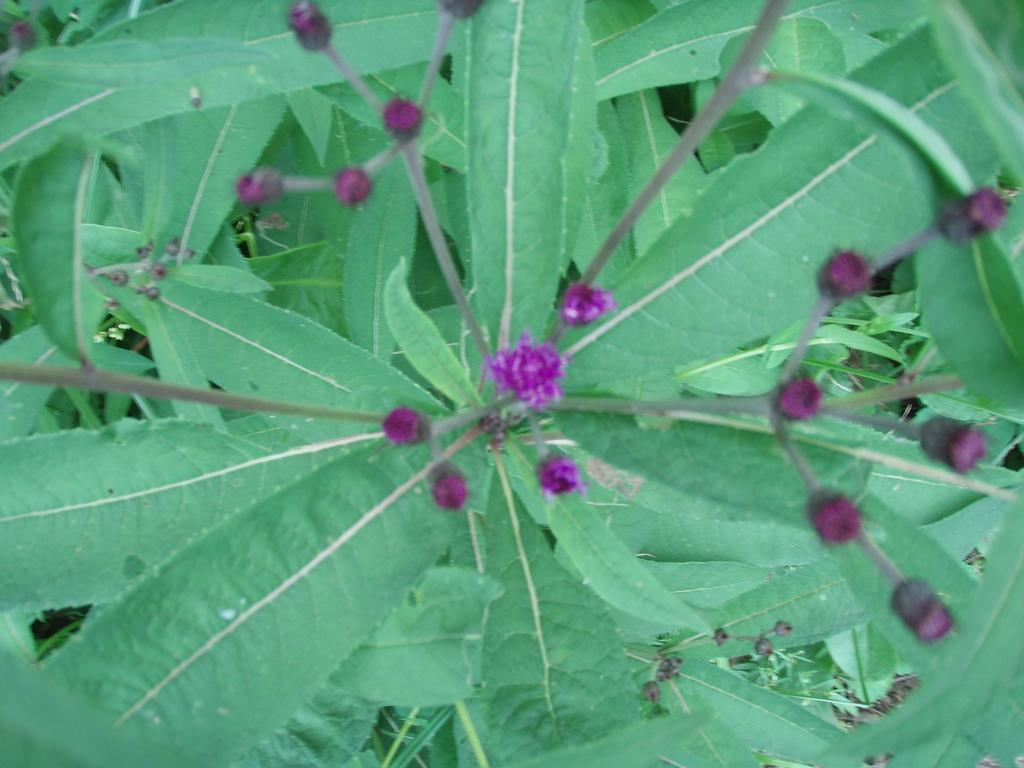What type of plant material can be seen in the image? There are leaves and buds in the image. Can you describe the stage of growth of the plant material? The presence of both leaves and buds suggests that the plant is in a stage of growth where it is producing both mature leaves and new growth. What type of horse can be seen in the image? There is no horse present in the image; it only contains leaves and buds. Can you tell me where the nearest store is in the image? There is no store present in the image; it only contains leaves and buds. 